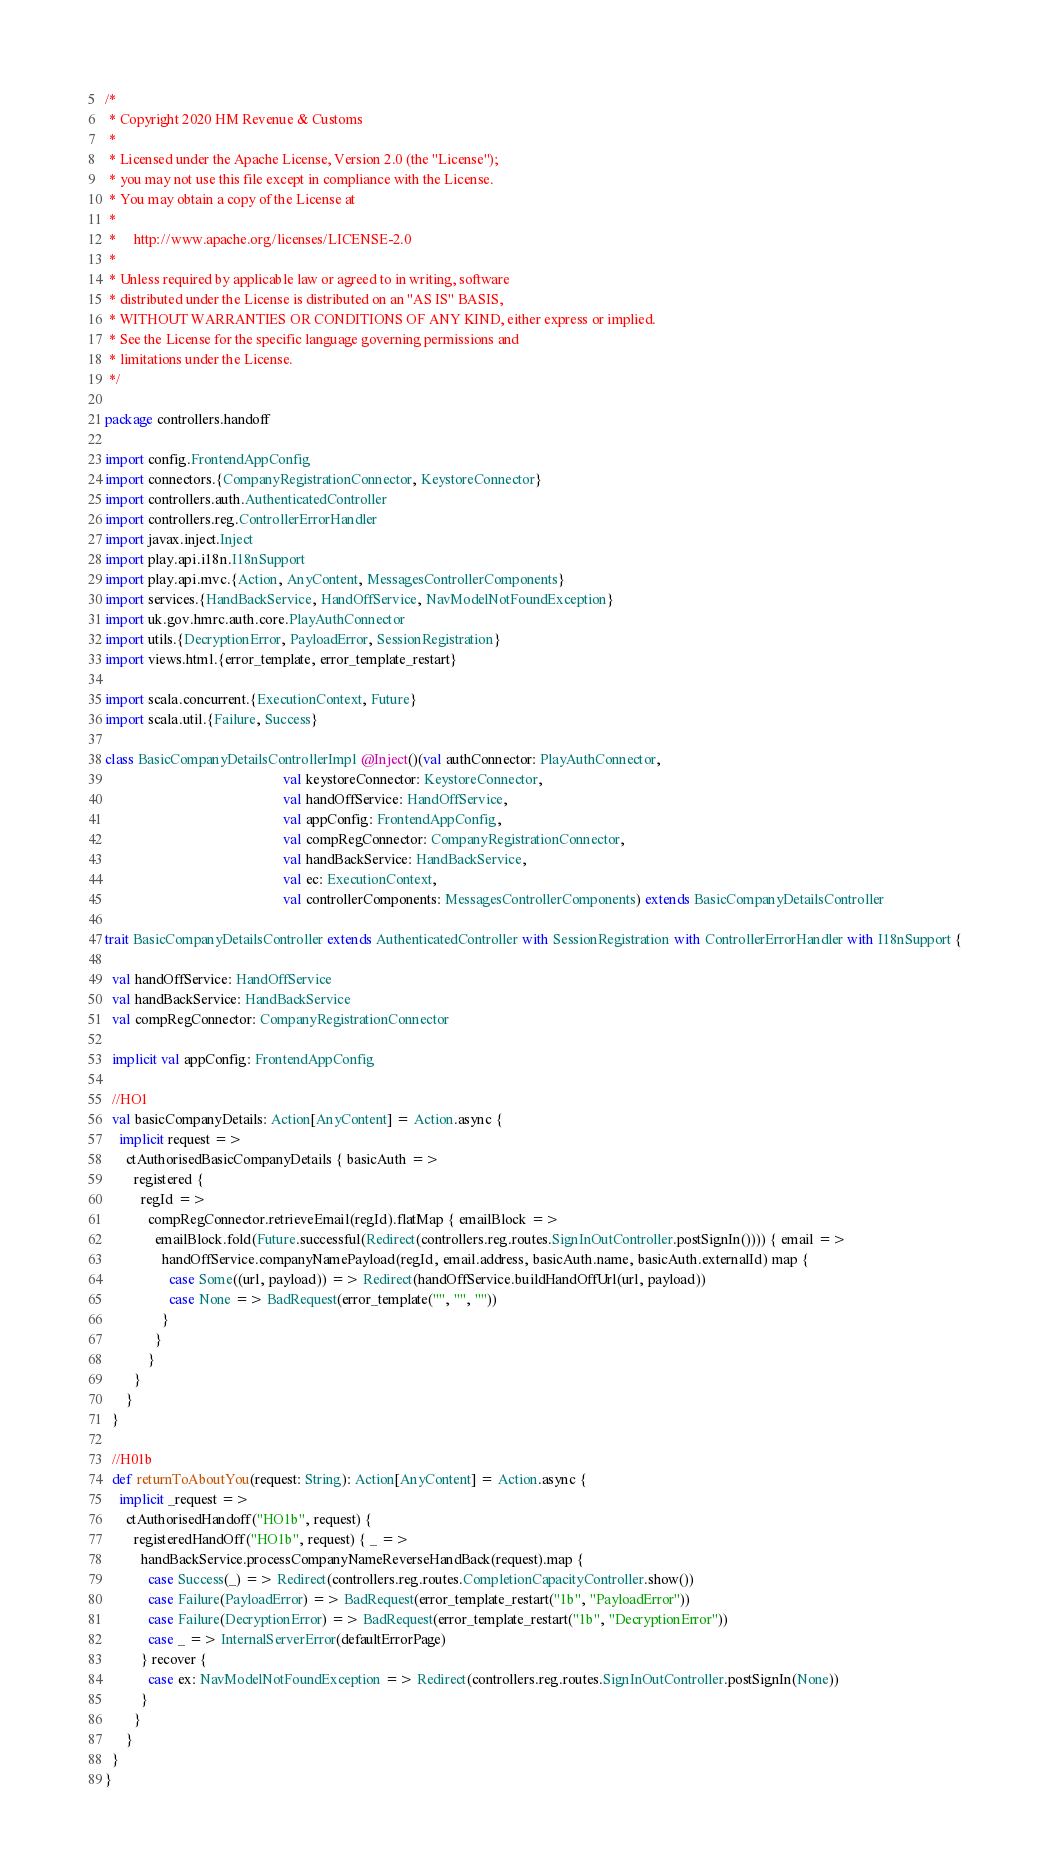Convert code to text. <code><loc_0><loc_0><loc_500><loc_500><_Scala_>/*
 * Copyright 2020 HM Revenue & Customs
 *
 * Licensed under the Apache License, Version 2.0 (the "License");
 * you may not use this file except in compliance with the License.
 * You may obtain a copy of the License at
 *
 *     http://www.apache.org/licenses/LICENSE-2.0
 *
 * Unless required by applicable law or agreed to in writing, software
 * distributed under the License is distributed on an "AS IS" BASIS,
 * WITHOUT WARRANTIES OR CONDITIONS OF ANY KIND, either express or implied.
 * See the License for the specific language governing permissions and
 * limitations under the License.
 */

package controllers.handoff

import config.FrontendAppConfig
import connectors.{CompanyRegistrationConnector, KeystoreConnector}
import controllers.auth.AuthenticatedController
import controllers.reg.ControllerErrorHandler
import javax.inject.Inject
import play.api.i18n.I18nSupport
import play.api.mvc.{Action, AnyContent, MessagesControllerComponents}
import services.{HandBackService, HandOffService, NavModelNotFoundException}
import uk.gov.hmrc.auth.core.PlayAuthConnector
import utils.{DecryptionError, PayloadError, SessionRegistration}
import views.html.{error_template, error_template_restart}

import scala.concurrent.{ExecutionContext, Future}
import scala.util.{Failure, Success}

class BasicCompanyDetailsControllerImpl @Inject()(val authConnector: PlayAuthConnector,
                                                  val keystoreConnector: KeystoreConnector,
                                                  val handOffService: HandOffService,
                                                  val appConfig: FrontendAppConfig,
                                                  val compRegConnector: CompanyRegistrationConnector,
                                                  val handBackService: HandBackService,
                                                  val ec: ExecutionContext,
                                                  val controllerComponents: MessagesControllerComponents) extends BasicCompanyDetailsController

trait BasicCompanyDetailsController extends AuthenticatedController with SessionRegistration with ControllerErrorHandler with I18nSupport {

  val handOffService: HandOffService
  val handBackService: HandBackService
  val compRegConnector: CompanyRegistrationConnector

  implicit val appConfig: FrontendAppConfig

  //HO1
  val basicCompanyDetails: Action[AnyContent] = Action.async {
    implicit request =>
      ctAuthorisedBasicCompanyDetails { basicAuth =>
        registered {
          regId =>
            compRegConnector.retrieveEmail(regId).flatMap { emailBlock =>
              emailBlock.fold(Future.successful(Redirect(controllers.reg.routes.SignInOutController.postSignIn()))) { email =>
                handOffService.companyNamePayload(regId, email.address, basicAuth.name, basicAuth.externalId) map {
                  case Some((url, payload)) => Redirect(handOffService.buildHandOffUrl(url, payload))
                  case None => BadRequest(error_template("", "", ""))
                }
              }
            }
        }
      }
  }

  //H01b
  def returnToAboutYou(request: String): Action[AnyContent] = Action.async {
    implicit _request =>
      ctAuthorisedHandoff("HO1b", request) {
        registeredHandOff("HO1b", request) { _ =>
          handBackService.processCompanyNameReverseHandBack(request).map {
            case Success(_) => Redirect(controllers.reg.routes.CompletionCapacityController.show())
            case Failure(PayloadError) => BadRequest(error_template_restart("1b", "PayloadError"))
            case Failure(DecryptionError) => BadRequest(error_template_restart("1b", "DecryptionError"))
            case _ => InternalServerError(defaultErrorPage)
          } recover {
            case ex: NavModelNotFoundException => Redirect(controllers.reg.routes.SignInOutController.postSignIn(None))
          }
        }
      }
  }
}</code> 